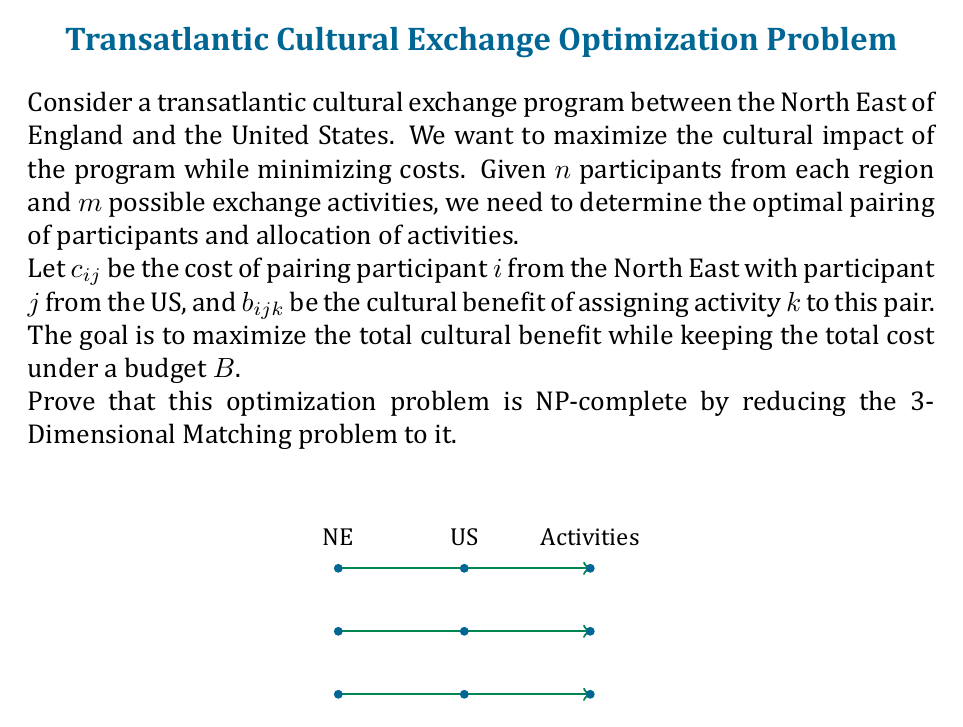Show me your answer to this math problem. To prove that this optimization problem is NP-complete, we need to show that it is in NP and that it is NP-hard. We'll focus on proving it's NP-hard by reducing the 3-Dimensional Matching problem to our problem.

Step 1: 3-Dimensional Matching (3DM) Problem
The 3DM problem is known to be NP-complete. It is defined as follows:
Given three sets $X$, $Y$, and $Z$, each of size $n$, and a set of triples $T \subseteq X \times Y \times Z$, determine if there exists a subset $M \subseteq T$ such that $|M| = n$ and no two elements of $M$ agree in any coordinate.

Step 2: Reduction
We'll reduce 3DM to our cultural exchange problem:
- Let $X$ represent participants from the North East, $Y$ represent participants from the US, and $Z$ represent activities.
- For each triple $(x_i, y_j, z_k) \in T$, set $c_{ij} = 1$ and $b_{ijk} = n+1$.
- For all other combinations, set $c_{ij} = n+1$ and $b_{ijk} = 0$.
- Set the budget $B = n$.

Step 3: Equivalence
Now, we need to show that a solution to 3DM exists if and only if there's a solution to our cultural exchange problem with a total benefit of $n(n+1)$.

If there's a solution to 3DM:
- We can select the corresponding pairs and activities in our problem.
- This will result in a total cost of $n$ (within budget) and a total benefit of $n(n+1)$.

If there's a solution to our problem with benefit $n(n+1)$:
- It must use exactly $n$ triples from $T$, as any other combination would exceed the budget or have less benefit.
- These $n$ triples form a valid 3D matching.

Step 4: Polynomial-time Reduction
This reduction can be done in polynomial time, as we're simply creating a one-to-one mapping between the problems.

Step 5: NP Verification
A solution to our problem can be verified in polynomial time by checking if the total cost is within budget and calculating the total benefit.

Therefore, our cultural exchange optimization problem is NP-complete.
Answer: NP-complete 